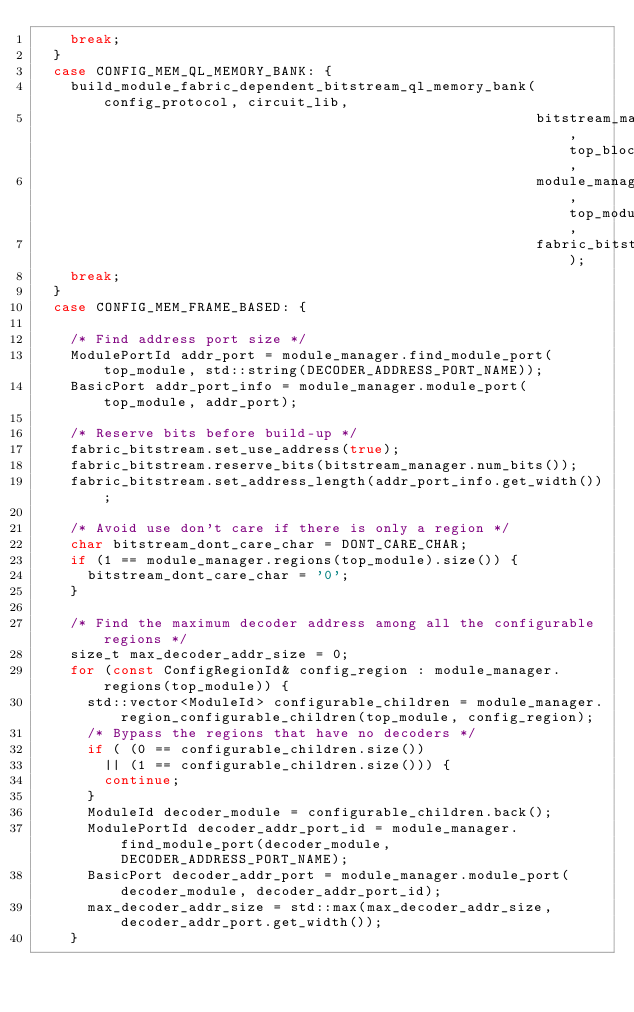Convert code to text. <code><loc_0><loc_0><loc_500><loc_500><_C++_>    break;
  }
  case CONFIG_MEM_QL_MEMORY_BANK: { 
    build_module_fabric_dependent_bitstream_ql_memory_bank(config_protocol, circuit_lib,
                                                           bitstream_manager, top_block,
                                                           module_manager, top_module, 
                                                           fabric_bitstream);
    break;
  }
  case CONFIG_MEM_FRAME_BASED: {

    /* Find address port size */
    ModulePortId addr_port = module_manager.find_module_port(top_module, std::string(DECODER_ADDRESS_PORT_NAME));
    BasicPort addr_port_info = module_manager.module_port(top_module, addr_port);

    /* Reserve bits before build-up */
    fabric_bitstream.set_use_address(true);
    fabric_bitstream.reserve_bits(bitstream_manager.num_bits());
    fabric_bitstream.set_address_length(addr_port_info.get_width());

    /* Avoid use don't care if there is only a region */
    char bitstream_dont_care_char = DONT_CARE_CHAR;
    if (1 == module_manager.regions(top_module).size()) {
      bitstream_dont_care_char = '0';
    }

    /* Find the maximum decoder address among all the configurable regions */
    size_t max_decoder_addr_size = 0;
    for (const ConfigRegionId& config_region : module_manager.regions(top_module)) {
      std::vector<ModuleId> configurable_children = module_manager.region_configurable_children(top_module, config_region);
      /* Bypass the regions that have no decoders */
      if ( (0 == configurable_children.size())
        || (1 == configurable_children.size())) {
        continue;
      }
      ModuleId decoder_module = configurable_children.back();
      ModulePortId decoder_addr_port_id = module_manager.find_module_port(decoder_module, DECODER_ADDRESS_PORT_NAME);
      BasicPort decoder_addr_port = module_manager.module_port(decoder_module, decoder_addr_port_id);
      max_decoder_addr_size = std::max(max_decoder_addr_size, decoder_addr_port.get_width()); 
    }
</code> 